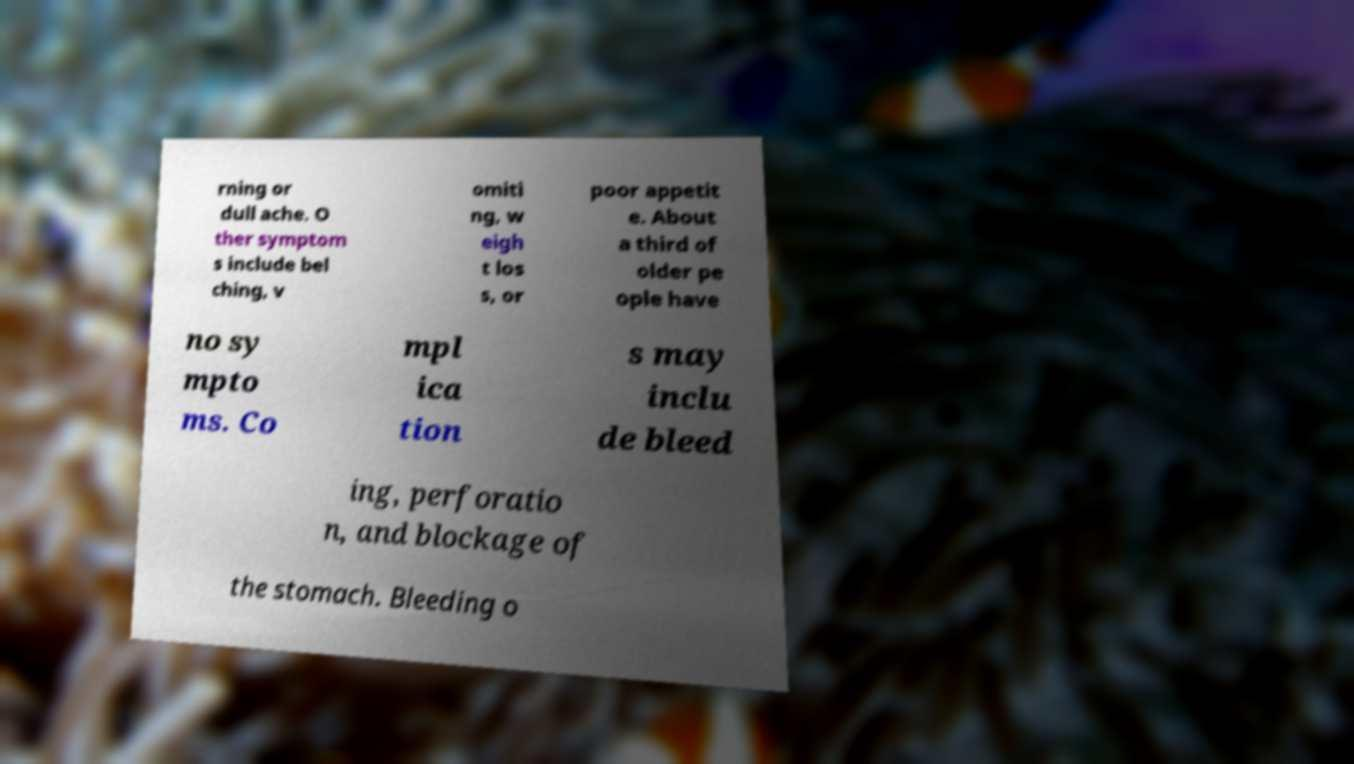What messages or text are displayed in this image? I need them in a readable, typed format. rning or dull ache. O ther symptom s include bel ching, v omiti ng, w eigh t los s, or poor appetit e. About a third of older pe ople have no sy mpto ms. Co mpl ica tion s may inclu de bleed ing, perforatio n, and blockage of the stomach. Bleeding o 